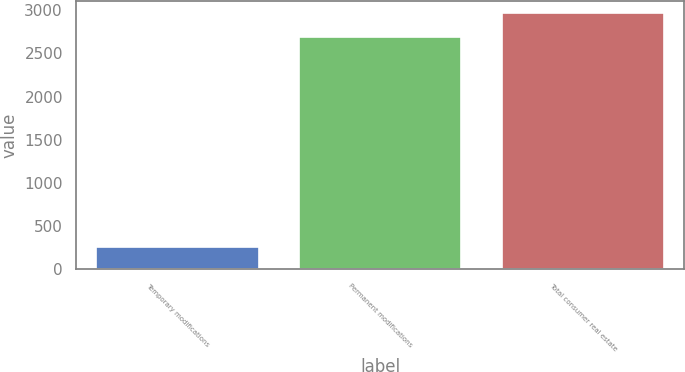Convert chart. <chart><loc_0><loc_0><loc_500><loc_500><bar_chart><fcel>Temporary modifications<fcel>Permanent modifications<fcel>Total consumer real estate<nl><fcel>258<fcel>2693<fcel>2962.3<nl></chart> 